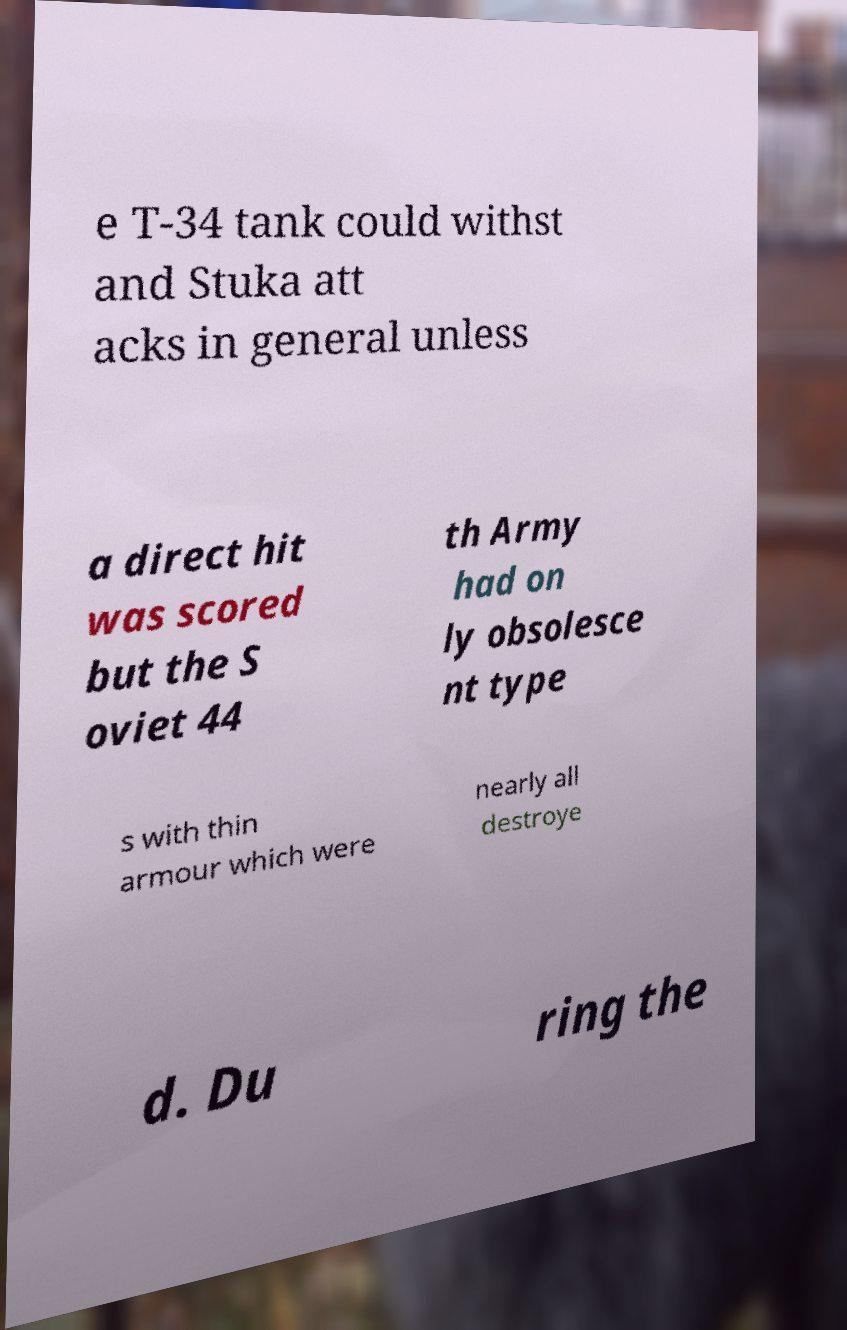What messages or text are displayed in this image? I need them in a readable, typed format. e T-34 tank could withst and Stuka att acks in general unless a direct hit was scored but the S oviet 44 th Army had on ly obsolesce nt type s with thin armour which were nearly all destroye d. Du ring the 